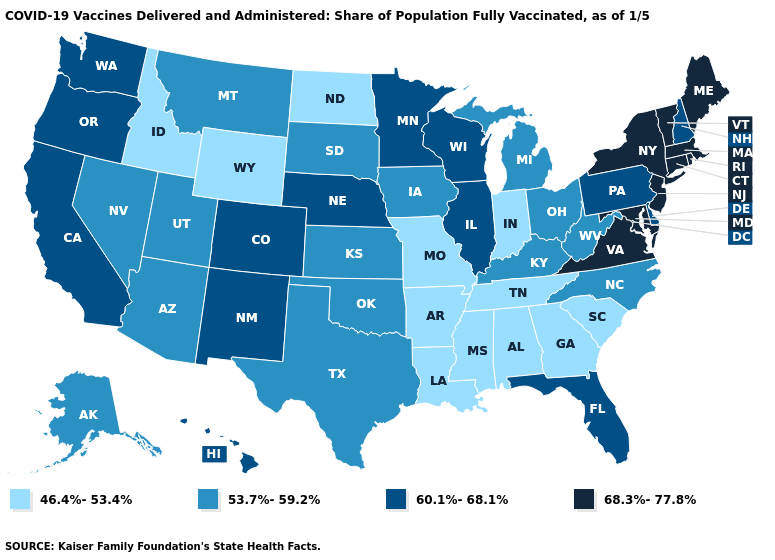Does Kentucky have a lower value than Kansas?
Short answer required. No. Among the states that border Iowa , which have the highest value?
Quick response, please. Illinois, Minnesota, Nebraska, Wisconsin. Name the states that have a value in the range 46.4%-53.4%?
Answer briefly. Alabama, Arkansas, Georgia, Idaho, Indiana, Louisiana, Mississippi, Missouri, North Dakota, South Carolina, Tennessee, Wyoming. What is the value of Connecticut?
Concise answer only. 68.3%-77.8%. What is the value of Mississippi?
Be succinct. 46.4%-53.4%. Is the legend a continuous bar?
Give a very brief answer. No. Name the states that have a value in the range 60.1%-68.1%?
Quick response, please. California, Colorado, Delaware, Florida, Hawaii, Illinois, Minnesota, Nebraska, New Hampshire, New Mexico, Oregon, Pennsylvania, Washington, Wisconsin. What is the lowest value in the West?
Give a very brief answer. 46.4%-53.4%. Name the states that have a value in the range 46.4%-53.4%?
Write a very short answer. Alabama, Arkansas, Georgia, Idaho, Indiana, Louisiana, Mississippi, Missouri, North Dakota, South Carolina, Tennessee, Wyoming. What is the value of Virginia?
Be succinct. 68.3%-77.8%. Does West Virginia have the highest value in the South?
Answer briefly. No. How many symbols are there in the legend?
Answer briefly. 4. Name the states that have a value in the range 46.4%-53.4%?
Give a very brief answer. Alabama, Arkansas, Georgia, Idaho, Indiana, Louisiana, Mississippi, Missouri, North Dakota, South Carolina, Tennessee, Wyoming. Which states hav the highest value in the South?
Give a very brief answer. Maryland, Virginia. What is the value of Indiana?
Quick response, please. 46.4%-53.4%. 